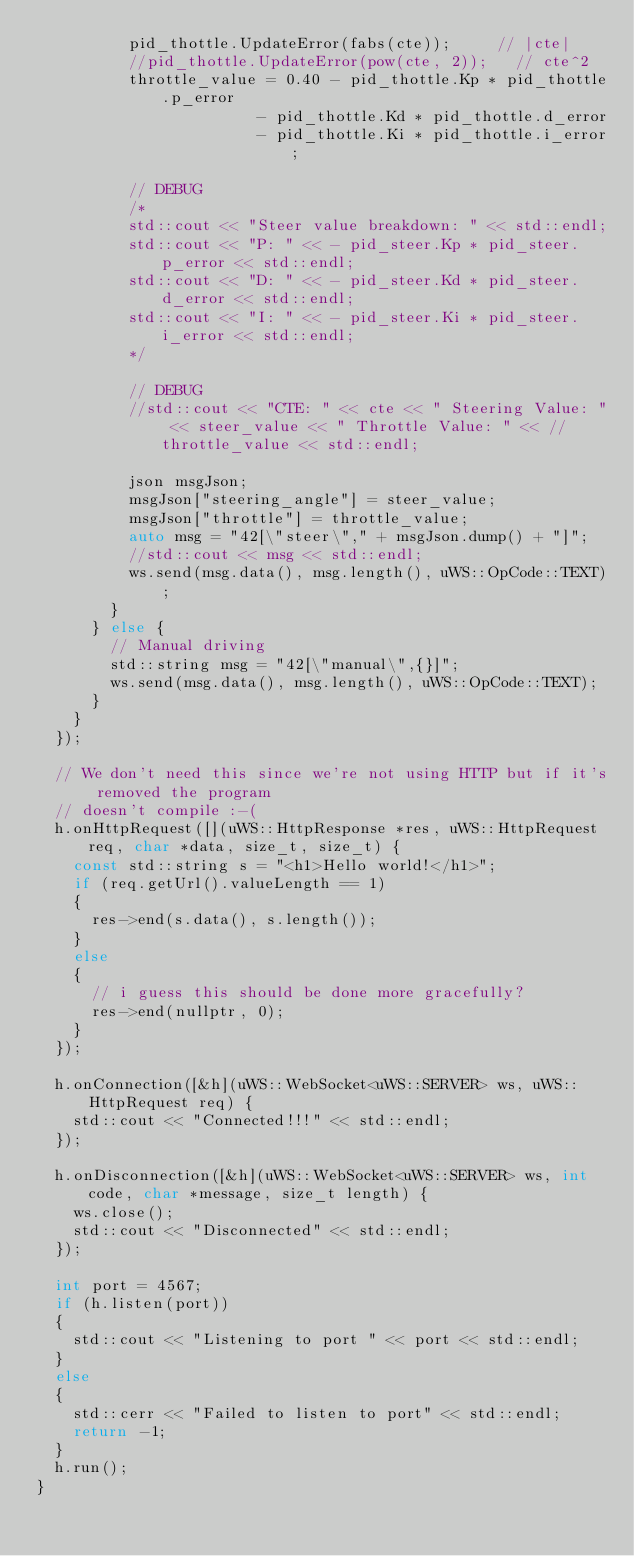Convert code to text. <code><loc_0><loc_0><loc_500><loc_500><_C++_>          pid_thottle.UpdateError(fabs(cte));     // |cte|
          //pid_thottle.UpdateError(pow(cte, 2));   // cte^2
          throttle_value = 0.40 - pid_thottle.Kp * pid_thottle.p_error
                        - pid_thottle.Kd * pid_thottle.d_error
                        - pid_thottle.Ki * pid_thottle.i_error;

          // DEBUG
          /*
          std::cout << "Steer value breakdown: " << std::endl;
          std::cout << "P: " << - pid_steer.Kp * pid_steer.p_error << std::endl;
          std::cout << "D: " << - pid_steer.Kd * pid_steer.d_error << std::endl;
          std::cout << "I: " << - pid_steer.Ki * pid_steer.i_error << std::endl;
          */

          // DEBUG
          //std::cout << "CTE: " << cte << " Steering Value: " << steer_value << " Throttle Value: " << //throttle_value << std::endl;

          json msgJson;
          msgJson["steering_angle"] = steer_value;
          msgJson["throttle"] = throttle_value;
          auto msg = "42[\"steer\"," + msgJson.dump() + "]";
          //std::cout << msg << std::endl;
          ws.send(msg.data(), msg.length(), uWS::OpCode::TEXT);
        }
      } else {
        // Manual driving
        std::string msg = "42[\"manual\",{}]";
        ws.send(msg.data(), msg.length(), uWS::OpCode::TEXT);
      }
    }
  });

  // We don't need this since we're not using HTTP but if it's removed the program
  // doesn't compile :-(
  h.onHttpRequest([](uWS::HttpResponse *res, uWS::HttpRequest req, char *data, size_t, size_t) {
    const std::string s = "<h1>Hello world!</h1>";
    if (req.getUrl().valueLength == 1)
    {
      res->end(s.data(), s.length());
    }
    else
    {
      // i guess this should be done more gracefully?
      res->end(nullptr, 0);
    }
  });

  h.onConnection([&h](uWS::WebSocket<uWS::SERVER> ws, uWS::HttpRequest req) {
    std::cout << "Connected!!!" << std::endl;
  });

  h.onDisconnection([&h](uWS::WebSocket<uWS::SERVER> ws, int code, char *message, size_t length) {
    ws.close();
    std::cout << "Disconnected" << std::endl;
  });

  int port = 4567;
  if (h.listen(port))
  {
    std::cout << "Listening to port " << port << std::endl;
  }
  else
  {
    std::cerr << "Failed to listen to port" << std::endl;
    return -1;
  }
  h.run();
}
</code> 